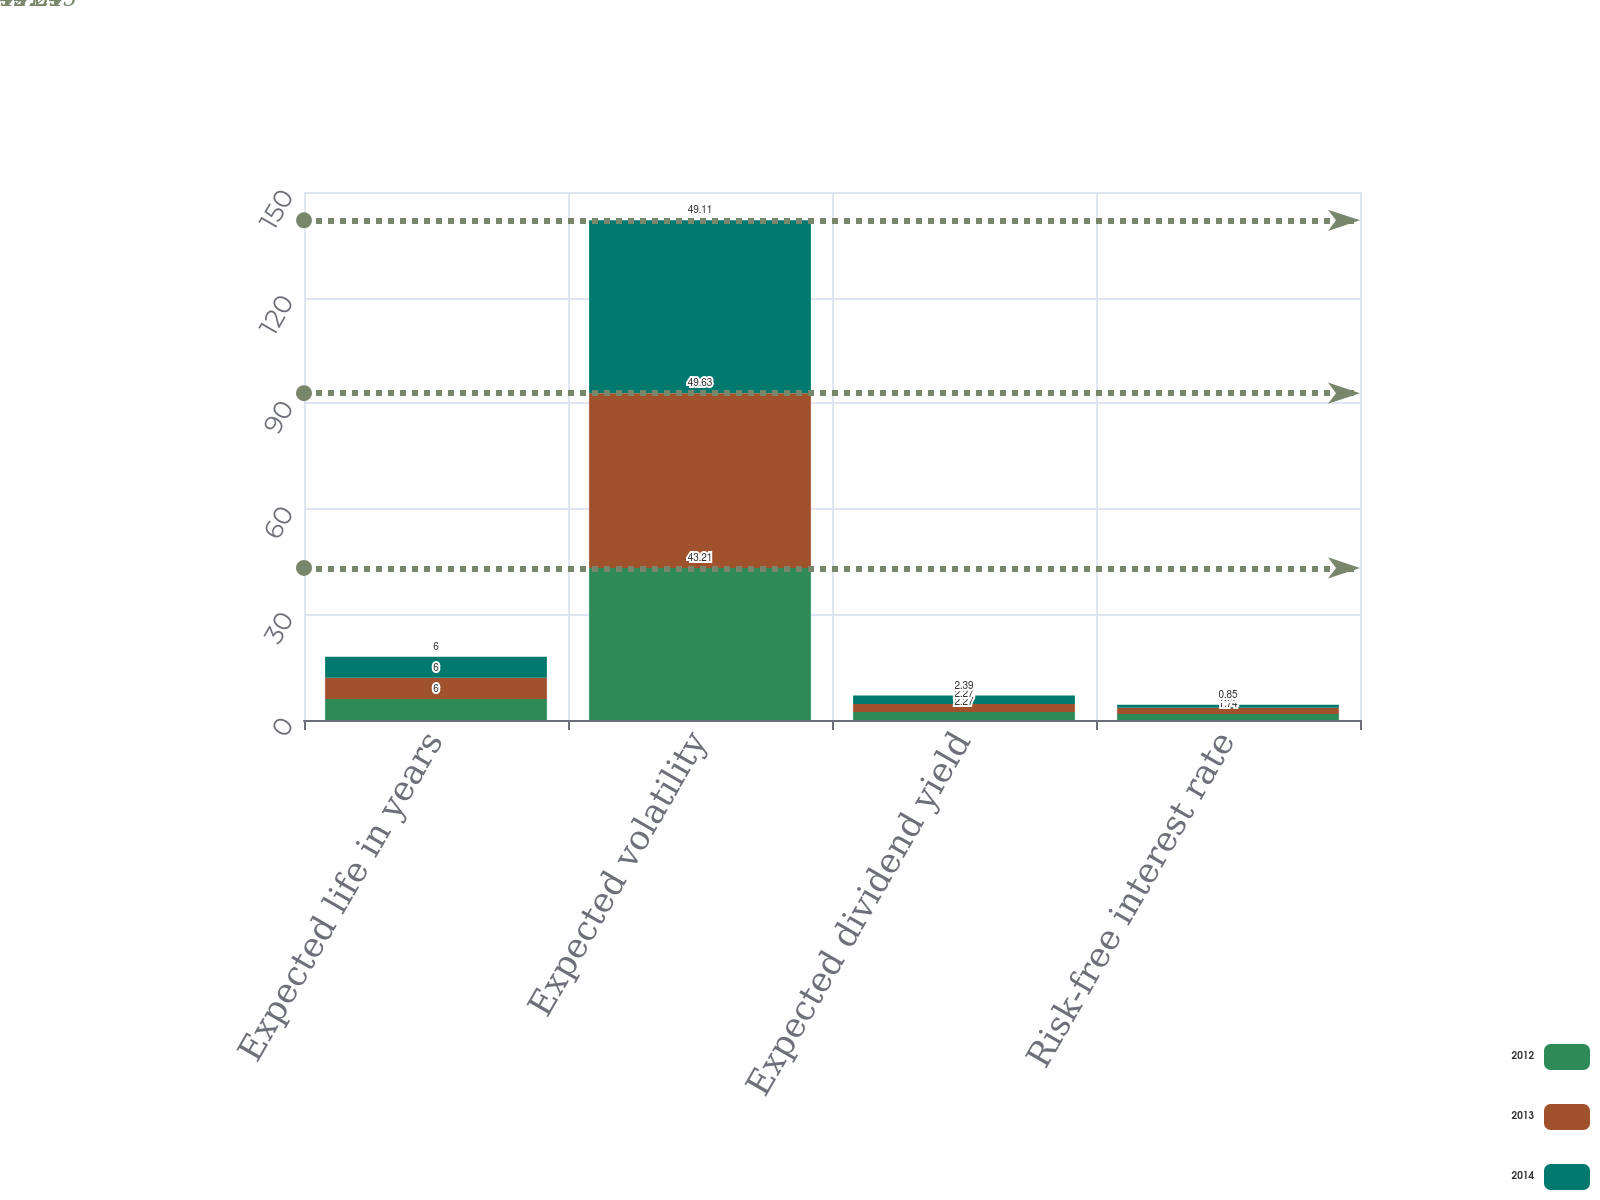Convert chart. <chart><loc_0><loc_0><loc_500><loc_500><stacked_bar_chart><ecel><fcel>Expected life in years<fcel>Expected volatility<fcel>Expected dividend yield<fcel>Risk-free interest rate<nl><fcel>2012<fcel>6<fcel>43.21<fcel>2.27<fcel>1.74<nl><fcel>2013<fcel>6<fcel>49.63<fcel>2.27<fcel>1.77<nl><fcel>2014<fcel>6<fcel>49.11<fcel>2.39<fcel>0.85<nl></chart> 